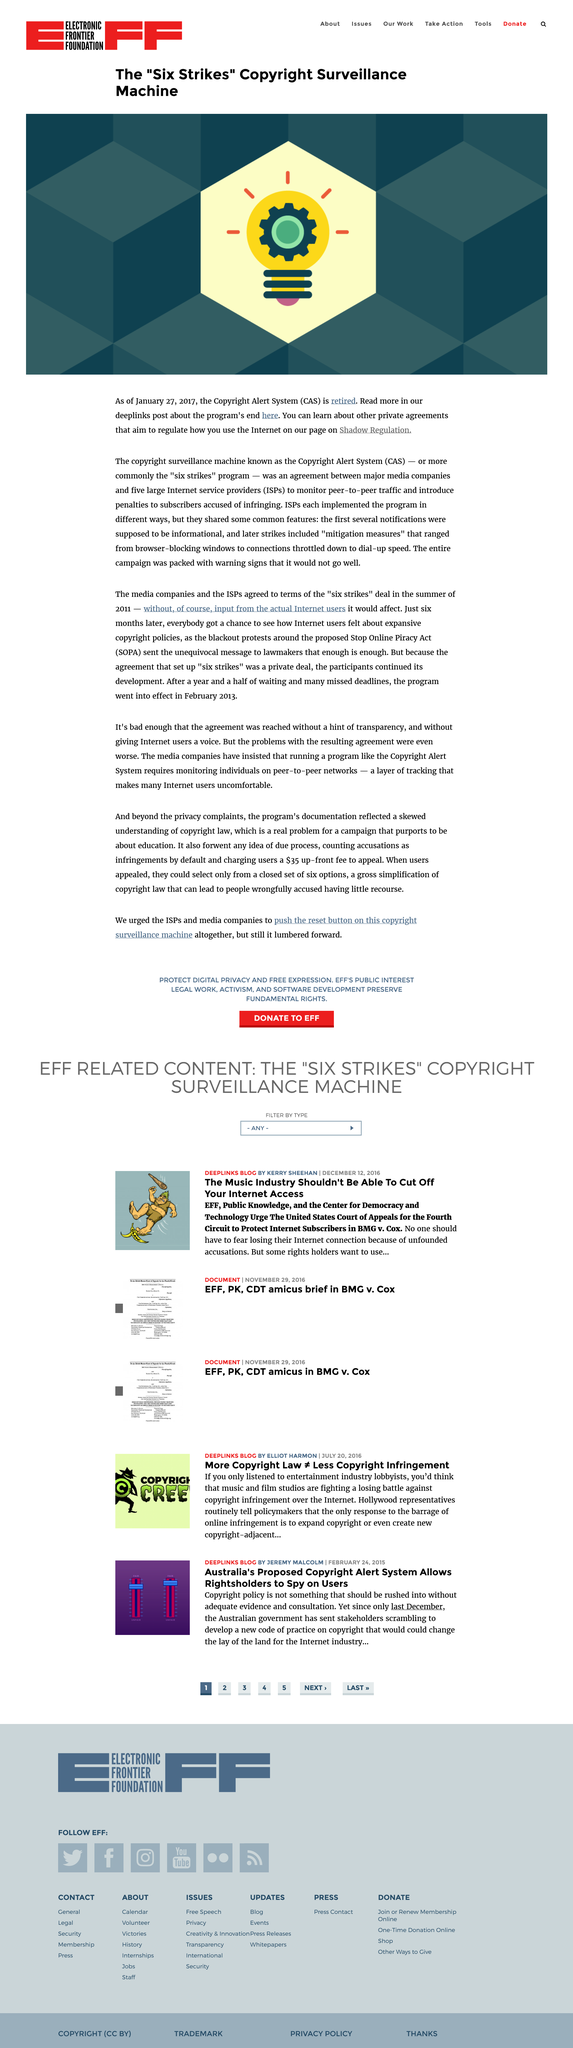Mention a couple of crucial points in this snapshot. Internet Service Providers" is an acronym that stands for "ISPs. The acronym "CAS" is an abbreviation for the term "Copyright Alert System. In 2017, the CAS system was retired. 